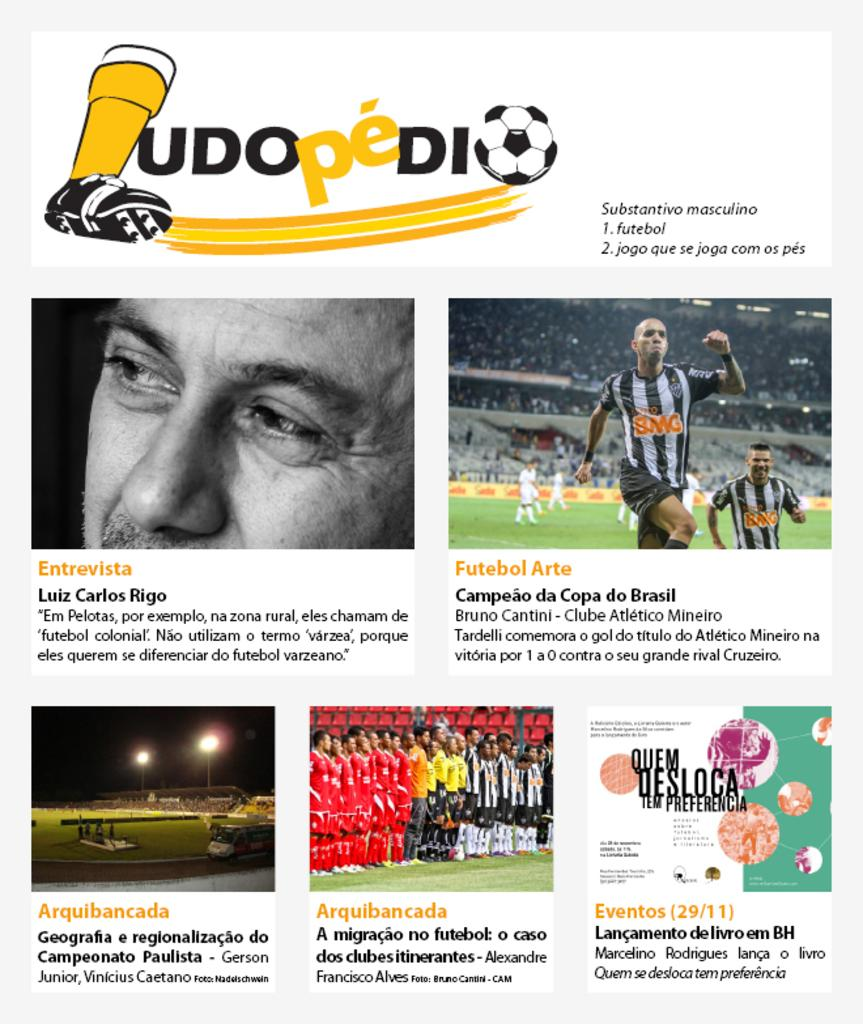What type of content is the image conveying? The image is an advertisement. What can be found within the image besides visual elements? There is text in the image. Can you describe the people in the image? There are persons in the image. What type of setting is depicted in the image? There is an auditorium in the image. What is the surface beneath the people and auditorium? There is a ground in the image. What is used to illuminate the scene in the image? There are lights in the image. Are there any branding elements in the image? There are logos in the image. What type of stem can be seen growing from the ground in the image? There is no stem growing from the ground in the image; it is a ground surface beneath the auditorium and people. What type of loaf is being served to the persons in the image? There is no loaf present in the image; it is an advertisement for an event or product. 